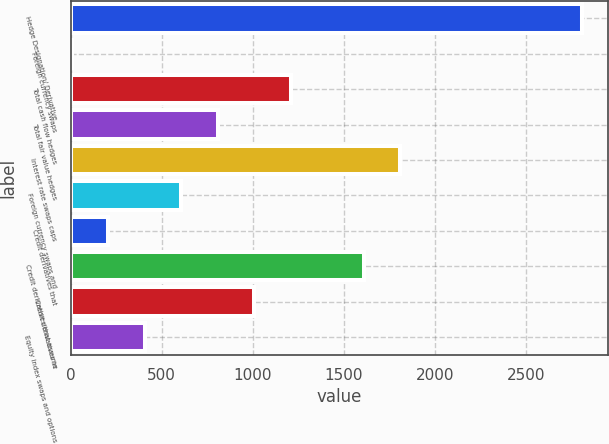Convert chart to OTSL. <chart><loc_0><loc_0><loc_500><loc_500><bar_chart><fcel>Hedge Designation/ Derivative<fcel>Foreign currency swaps<fcel>Total cash flow hedges<fcel>Total fair value hedges<fcel>Interest rate swaps caps<fcel>Foreign currency swaps and<fcel>Credit derivatives that<fcel>Credit derivatives that assume<fcel>Credit derivatives in<fcel>Equity index swaps and options<nl><fcel>2811.6<fcel>6<fcel>1208.4<fcel>807.6<fcel>1809.6<fcel>607.2<fcel>206.4<fcel>1609.2<fcel>1008<fcel>406.8<nl></chart> 